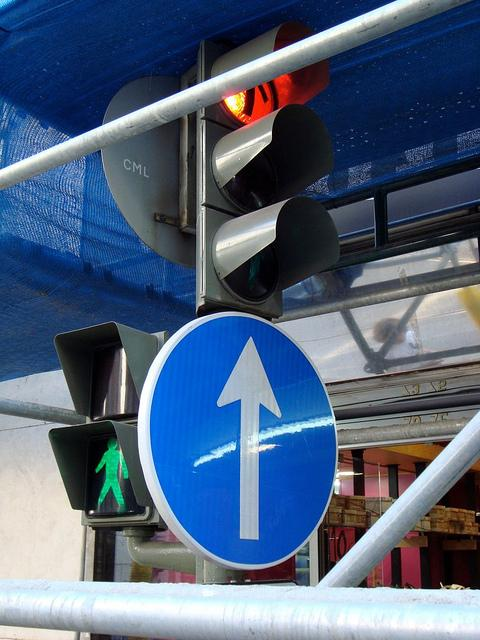What does the blue sign with a white arrow mean? Please explain your reasoning. ahead only. The direction on the sign is the way of the street. 